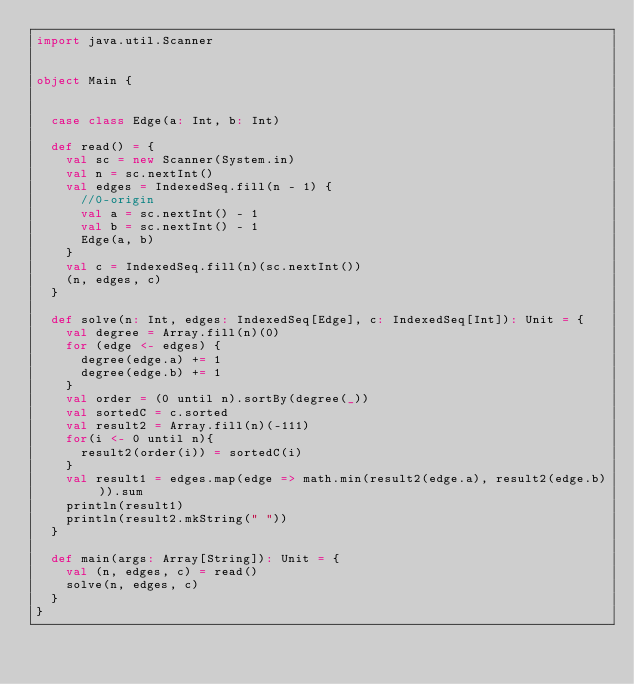<code> <loc_0><loc_0><loc_500><loc_500><_Scala_>import java.util.Scanner


object Main {


  case class Edge(a: Int, b: Int)

  def read() = {
    val sc = new Scanner(System.in)
    val n = sc.nextInt()
    val edges = IndexedSeq.fill(n - 1) {
      //0-origin
      val a = sc.nextInt() - 1
      val b = sc.nextInt() - 1
      Edge(a, b)
    }
    val c = IndexedSeq.fill(n)(sc.nextInt())
    (n, edges, c)
  }

  def solve(n: Int, edges: IndexedSeq[Edge], c: IndexedSeq[Int]): Unit = {
    val degree = Array.fill(n)(0)
    for (edge <- edges) {
      degree(edge.a) += 1
      degree(edge.b) += 1
    }
    val order = (0 until n).sortBy(degree(_))
    val sortedC = c.sorted
    val result2 = Array.fill(n)(-111)
    for(i <- 0 until n){
      result2(order(i)) = sortedC(i)
    }
    val result1 = edges.map(edge => math.min(result2(edge.a), result2(edge.b))).sum
    println(result1)
    println(result2.mkString(" "))
  }

  def main(args: Array[String]): Unit = {
    val (n, edges, c) = read()
    solve(n, edges, c)
  }
}
</code> 